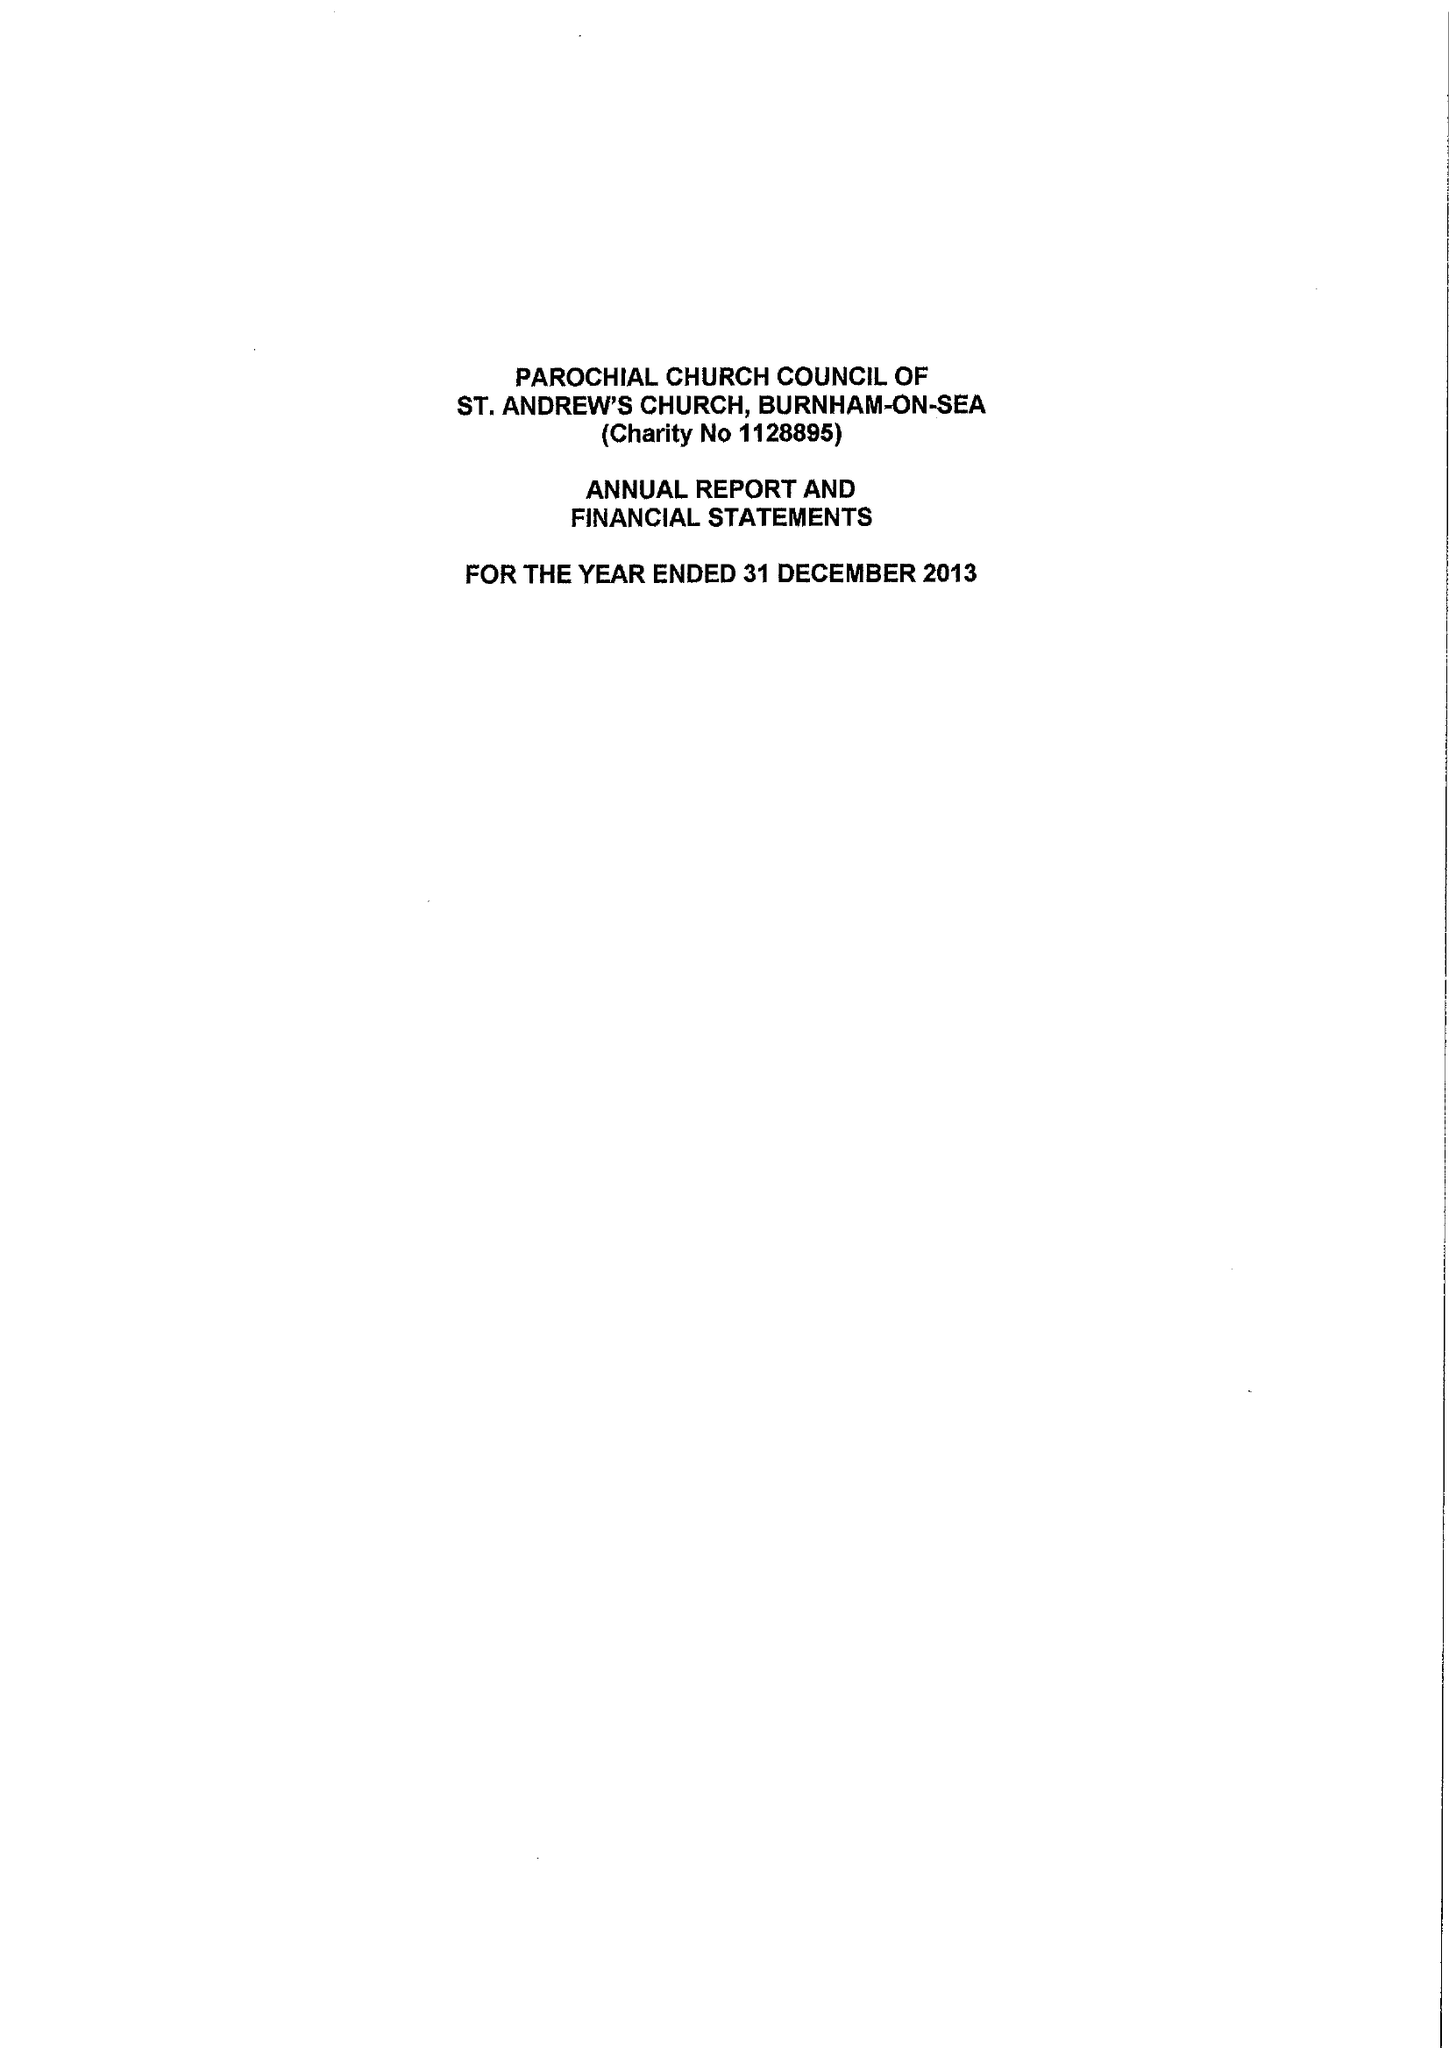What is the value for the report_date?
Answer the question using a single word or phrase. 2013-12-31 